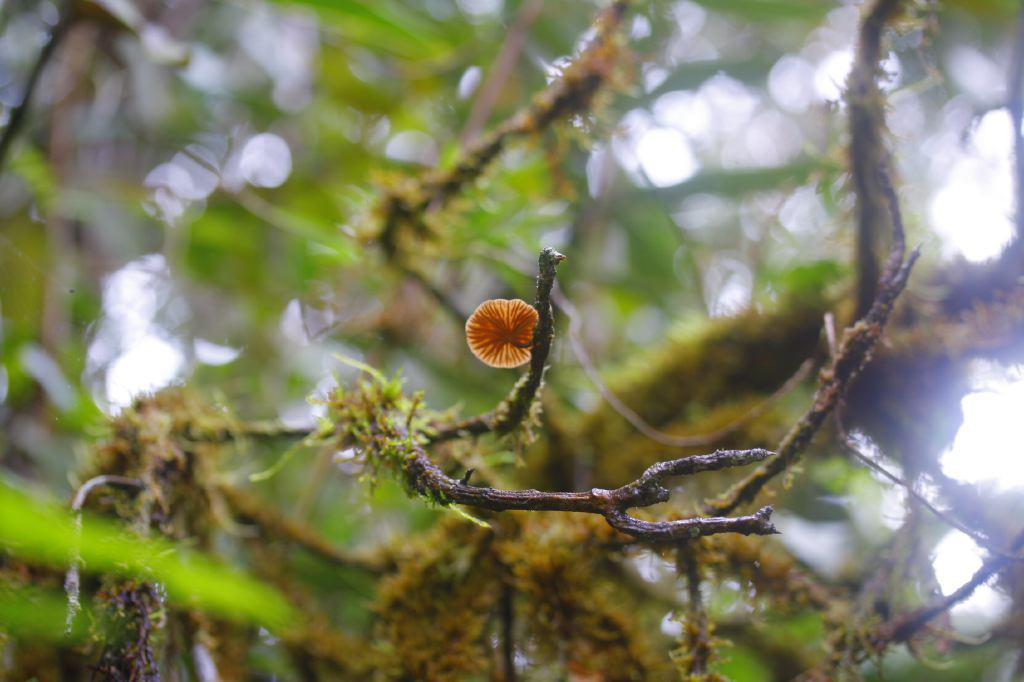What type of plant can be seen in the image? There is a tree in the image. What other type of plant can be seen in the image? There is a flower in the image. What type of hammer is being used to create the flower in the image? There is no hammer present in the image, and the flower is a natural object, not created by a hammer. 